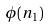<formula> <loc_0><loc_0><loc_500><loc_500>\phi ( n _ { 1 } )</formula> 